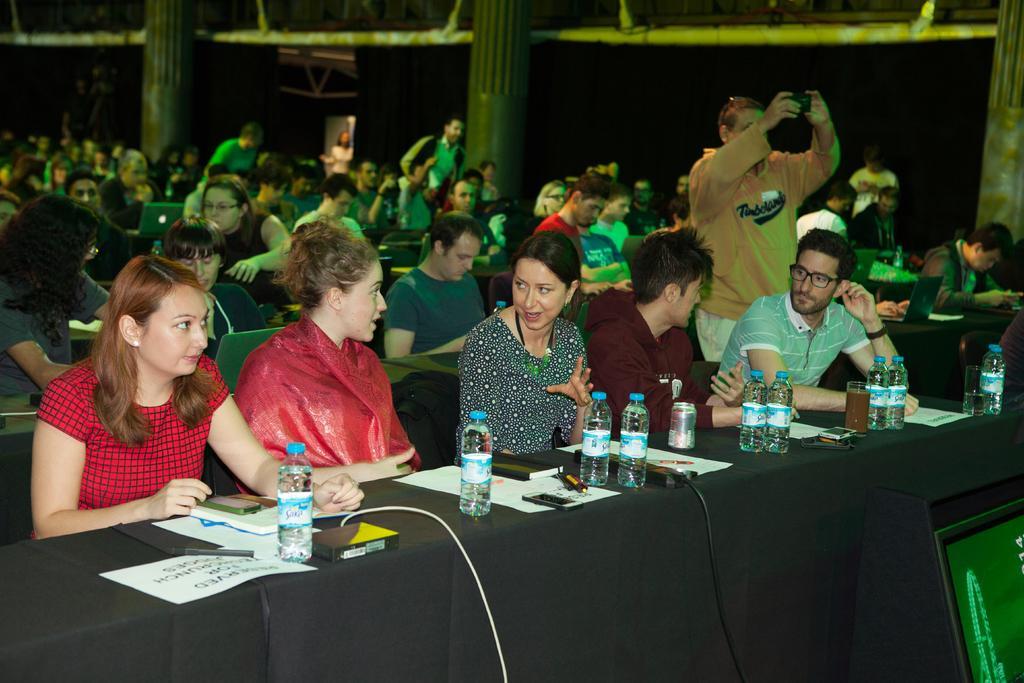Can you describe this image briefly? In this image I can see the group of people sitting. Among them one person is standing and the camera. In front of these people there is a table. On the table there are some papers and the bottles. 